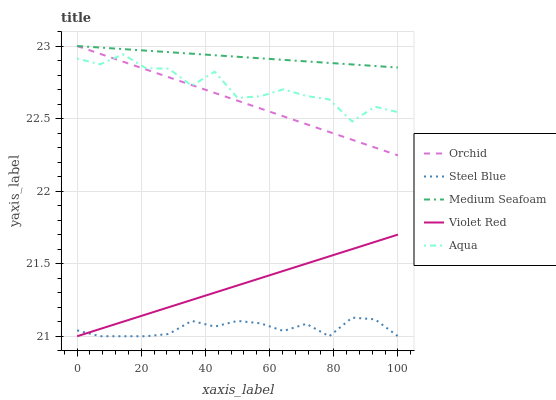Does Aqua have the minimum area under the curve?
Answer yes or no. No. Does Aqua have the maximum area under the curve?
Answer yes or no. No. Is Medium Seafoam the smoothest?
Answer yes or no. No. Is Medium Seafoam the roughest?
Answer yes or no. No. Does Aqua have the lowest value?
Answer yes or no. No. Does Aqua have the highest value?
Answer yes or no. No. Is Steel Blue less than Aqua?
Answer yes or no. Yes. Is Orchid greater than Violet Red?
Answer yes or no. Yes. Does Steel Blue intersect Aqua?
Answer yes or no. No. 